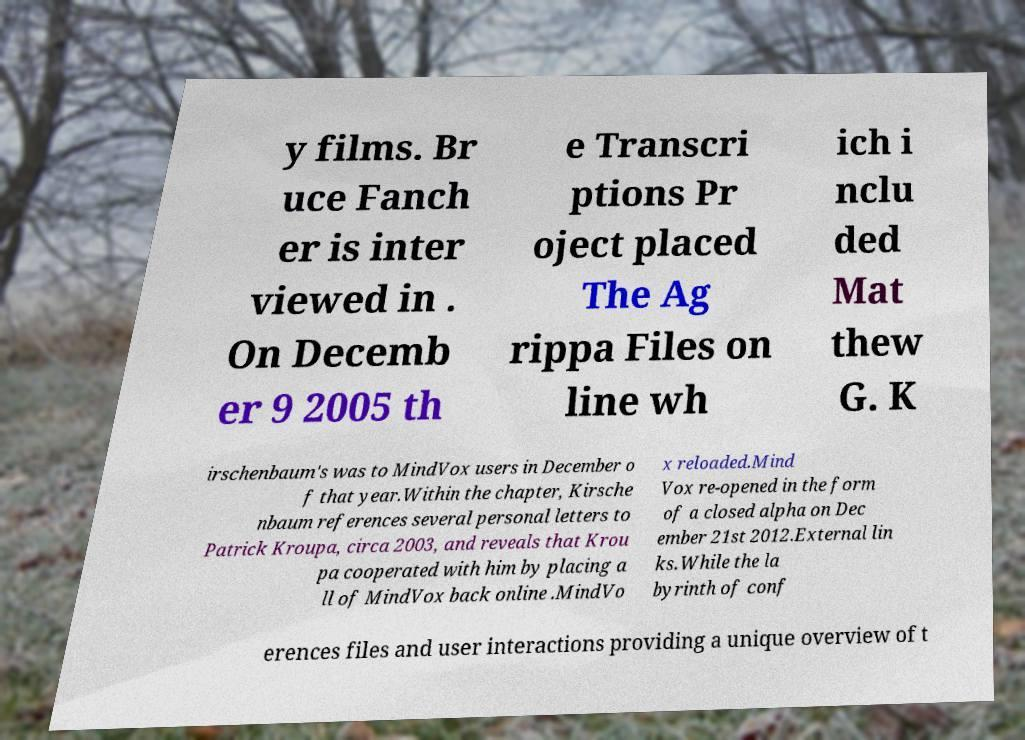Could you assist in decoding the text presented in this image and type it out clearly? y films. Br uce Fanch er is inter viewed in . On Decemb er 9 2005 th e Transcri ptions Pr oject placed The Ag rippa Files on line wh ich i nclu ded Mat thew G. K irschenbaum's was to MindVox users in December o f that year.Within the chapter, Kirsche nbaum references several personal letters to Patrick Kroupa, circa 2003, and reveals that Krou pa cooperated with him by placing a ll of MindVox back online .MindVo x reloaded.Mind Vox re-opened in the form of a closed alpha on Dec ember 21st 2012.External lin ks.While the la byrinth of conf erences files and user interactions providing a unique overview of t 